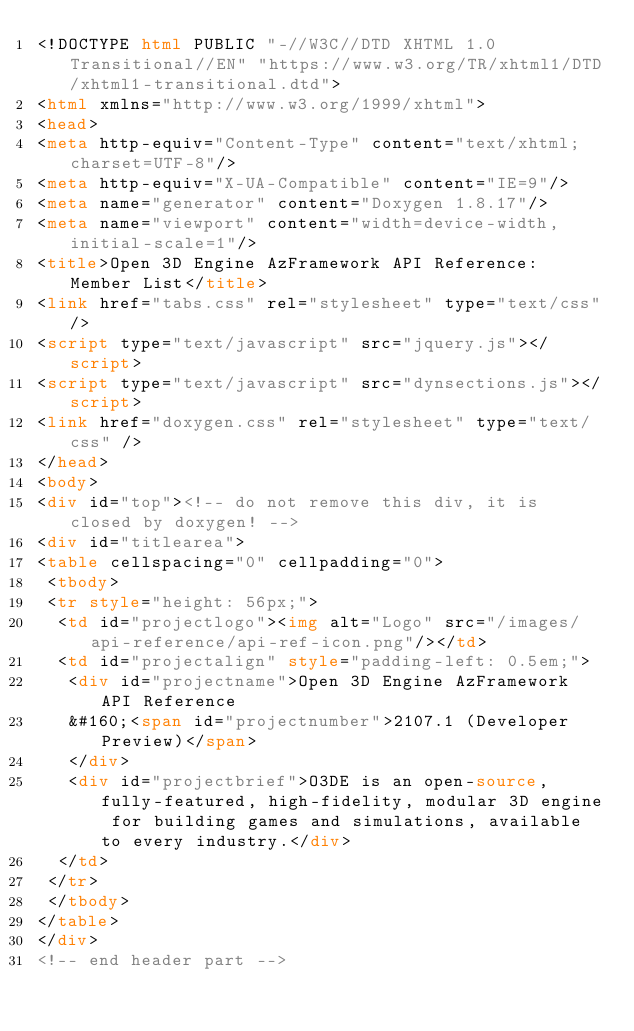<code> <loc_0><loc_0><loc_500><loc_500><_HTML_><!DOCTYPE html PUBLIC "-//W3C//DTD XHTML 1.0 Transitional//EN" "https://www.w3.org/TR/xhtml1/DTD/xhtml1-transitional.dtd">
<html xmlns="http://www.w3.org/1999/xhtml">
<head>
<meta http-equiv="Content-Type" content="text/xhtml;charset=UTF-8"/>
<meta http-equiv="X-UA-Compatible" content="IE=9"/>
<meta name="generator" content="Doxygen 1.8.17"/>
<meta name="viewport" content="width=device-width, initial-scale=1"/>
<title>Open 3D Engine AzFramework API Reference: Member List</title>
<link href="tabs.css" rel="stylesheet" type="text/css"/>
<script type="text/javascript" src="jquery.js"></script>
<script type="text/javascript" src="dynsections.js"></script>
<link href="doxygen.css" rel="stylesheet" type="text/css" />
</head>
<body>
<div id="top"><!-- do not remove this div, it is closed by doxygen! -->
<div id="titlearea">
<table cellspacing="0" cellpadding="0">
 <tbody>
 <tr style="height: 56px;">
  <td id="projectlogo"><img alt="Logo" src="/images/api-reference/api-ref-icon.png"/></td>
  <td id="projectalign" style="padding-left: 0.5em;">
   <div id="projectname">Open 3D Engine AzFramework API Reference
   &#160;<span id="projectnumber">2107.1 (Developer Preview)</span>
   </div>
   <div id="projectbrief">O3DE is an open-source, fully-featured, high-fidelity, modular 3D engine for building games and simulations, available to every industry.</div>
  </td>
 </tr>
 </tbody>
</table>
</div>
<!-- end header part --></code> 